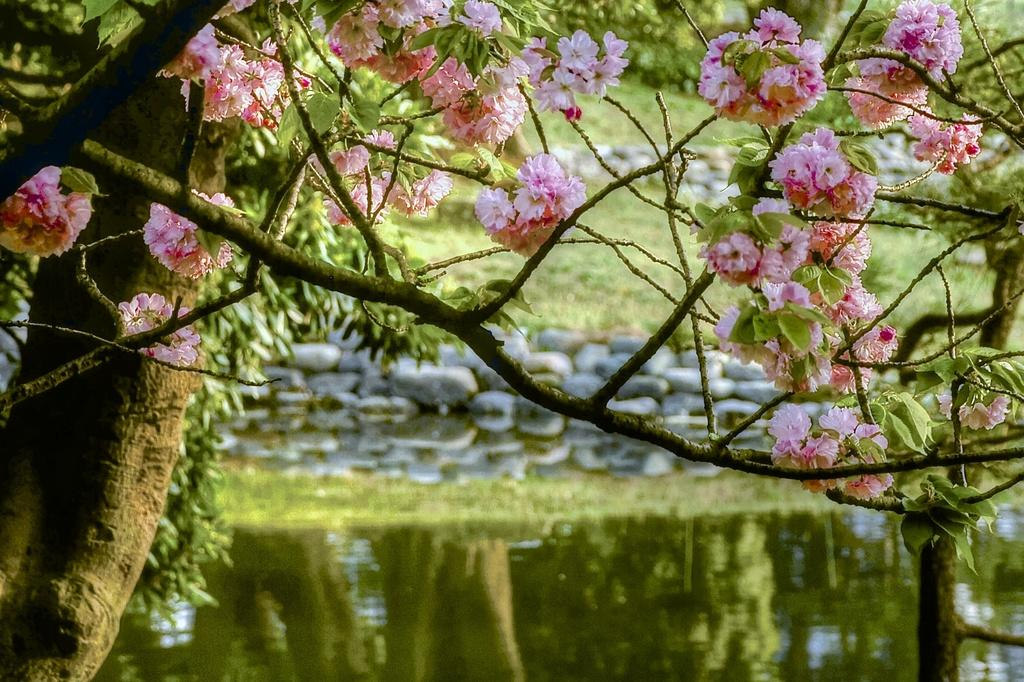What type of vegetation can be seen on the branches of a tree in the image? There are flowers on the branches of a tree in the image. What part of the tree is visible in the image? The bark of the tree is visible in the image. What type of ground cover is present in the image? There is grass in the image. What type of inorganic material is present in the image? There are stones in the image. What natural element is visible in the image? There is water visible in the image. What type of lawyer is sitting on the branch of the tree in the image? There is no lawyer present in the image; it features flowers on the branches of a tree. How many crows are visible in the image? There are no crows present in the image. 